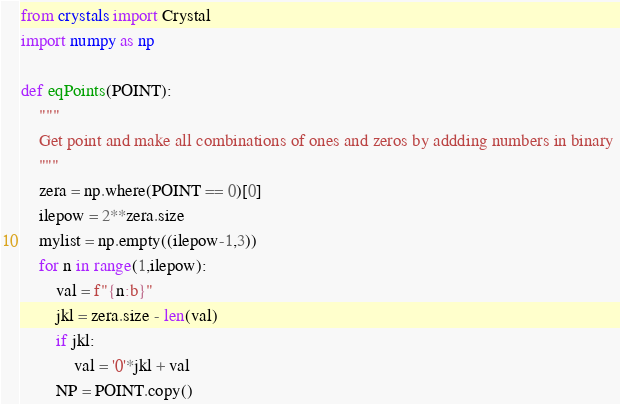Convert code to text. <code><loc_0><loc_0><loc_500><loc_500><_Python_>from crystals import Crystal
import numpy as np

def eqPoints(POINT):
    """
    Get point and make all combinations of ones and zeros by addding numbers in binary 
    """    
    zera = np.where(POINT == 0)[0]
    ilepow = 2**zera.size
    mylist = np.empty((ilepow-1,3))
    for n in range(1,ilepow):
        val = f"{n:b}" 
        jkl = zera.size - len(val)
        if jkl:
            val = '0'*jkl + val
        NP = POINT.copy()</code> 